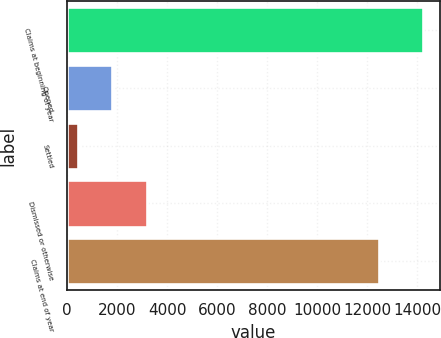<chart> <loc_0><loc_0><loc_500><loc_500><bar_chart><fcel>Claims at beginning of year<fcel>Opened<fcel>Settled<fcel>Dismissed or otherwise<fcel>Claims at end of year<nl><fcel>14215<fcel>1804.9<fcel>426<fcel>3183.8<fcel>12454<nl></chart> 